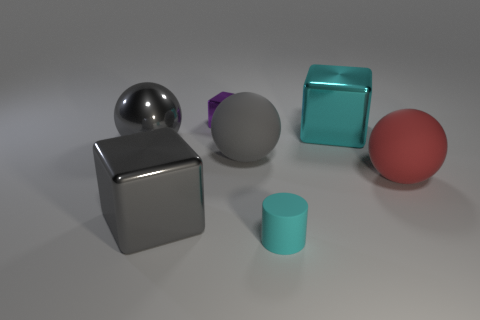Are there more big gray balls that are to the right of the big gray shiny sphere than small brown metallic blocks?
Provide a succinct answer. Yes. There is a large shiny object that is the same color as the small rubber cylinder; what shape is it?
Your response must be concise. Cube. Is there a tiny purple object made of the same material as the cyan block?
Your answer should be compact. Yes. Do the cyan object in front of the red sphere and the cyan thing that is behind the cyan matte thing have the same material?
Offer a terse response. No. Are there the same number of gray cubes that are to the right of the red sphere and big cyan things to the left of the large metallic ball?
Provide a short and direct response. Yes. What color is the shiny ball that is the same size as the red matte sphere?
Provide a short and direct response. Gray. Are there any tiny cylinders of the same color as the shiny sphere?
Keep it short and to the point. No. What number of things are either large shiny cubes on the left side of the tiny cyan cylinder or tiny purple cubes?
Provide a succinct answer. 2. How many other objects are the same size as the gray metallic block?
Provide a succinct answer. 4. What material is the gray ball that is to the right of the sphere that is to the left of the large shiny block left of the small purple metallic thing?
Provide a succinct answer. Rubber. 